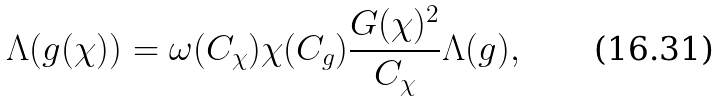Convert formula to latex. <formula><loc_0><loc_0><loc_500><loc_500>\Lambda ( g ( \chi ) ) = \omega ( C _ { \chi } ) \chi ( C _ { g } ) \frac { G ( \chi ) ^ { 2 } } { C _ { \chi } } \Lambda ( g ) ,</formula> 